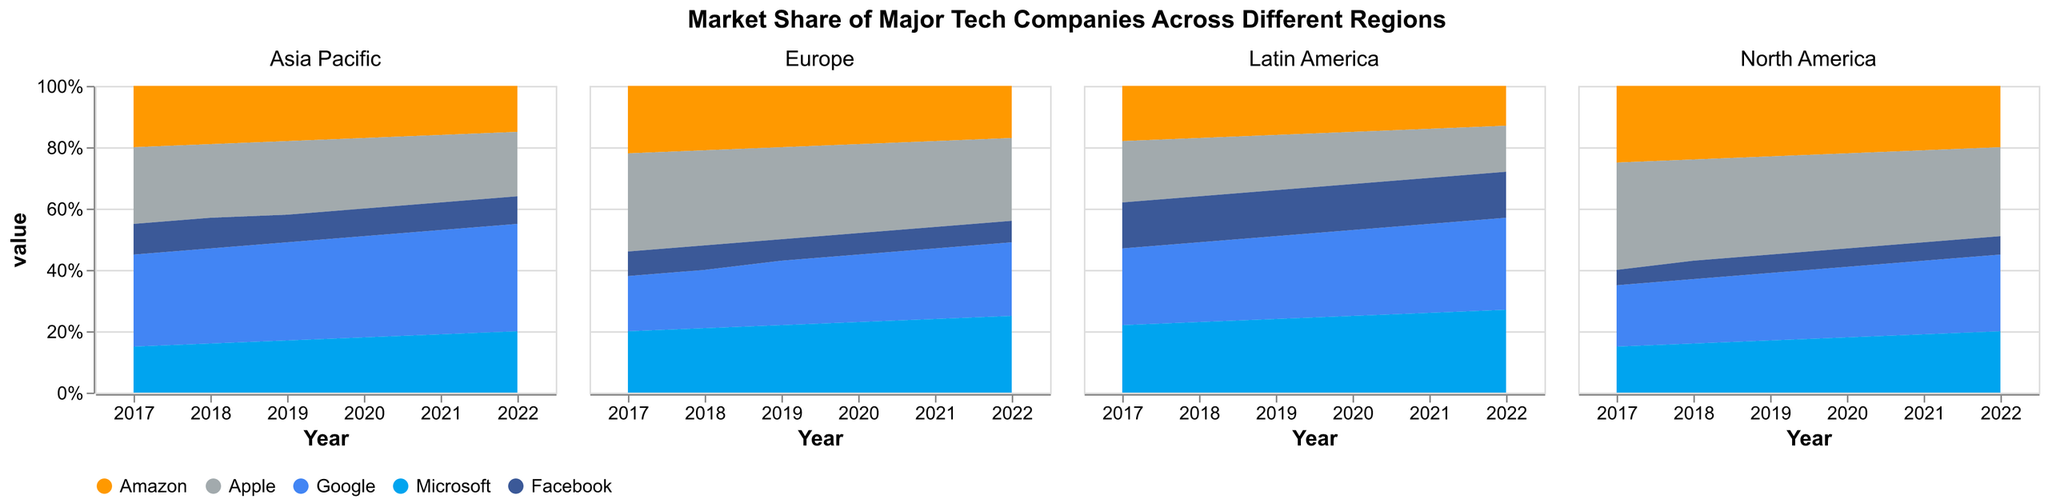what is the title of the figure? The title of the figure is located above all the subplots of the area chart.
Answer: Market Share of Major Tech Companies Across Different Regions What are the y-axis percentages for the year 2020 in North America? The y-axis percentages for different companies can be seen on the vertical axis for 2020 in the North America subplot. Each area represents the market share of each company.
Answer: Google: 23%, Apple: 31%, Microsoft: 18%, Amazon: 22%, Facebook: 6% Which company has the highest market share in the Asia Pacific region in 2022? By observing the stacked areas in the subplot titled 'Asia Pacific' for the year 2022, we can see the company with the largest area.
Answer: Google How did Amazon's market share change in Europe from 2017 to 2022? To determine this, observe the height of the area representing Amazon in the Europe subplot from 2017 to 2022. The area shrinks consistently within this period.
Answer: It decreased steadily Compare Apple and Microsoft's market shares in Latin America in 2021. Which company had more, and by how much? Check the heights of the areas representing Apple and Microsoft in the Latin America subplot for the year 2021. Subtract Apple's value from Microsoft's.
Answer: Microsoft had more by 10% In the North America region, which company had the most stable market share across the years 2017 to 2022? Evaluating the height of each company's area across the years in the North America subplot, the most stable one shows the least change.
Answer: Facebook Which region shows the largest increase in Google's market share from 2017 to 2022? By comparing the area representing Google in each subplot from 2017 to 2022, we notice the region where this area increases the most.
Answer: Asia Pacific What trend is observed in Microsoft's market share in Latin America from 2017 to 2022? Observe the area representing Microsoft in the Latin America subplot across these years. The area representing Microsoft increases progressively.
Answer: Increasing trend How does Facebook's market share in Europe in 2019 compare to that in the Asia Pacific in the same year? By comparing the respective heights of the Facebook areas in both the Europe and Asia Pacific subplots for the year 2019, we determine the relationship.
Answer: Europe is slightly higher 